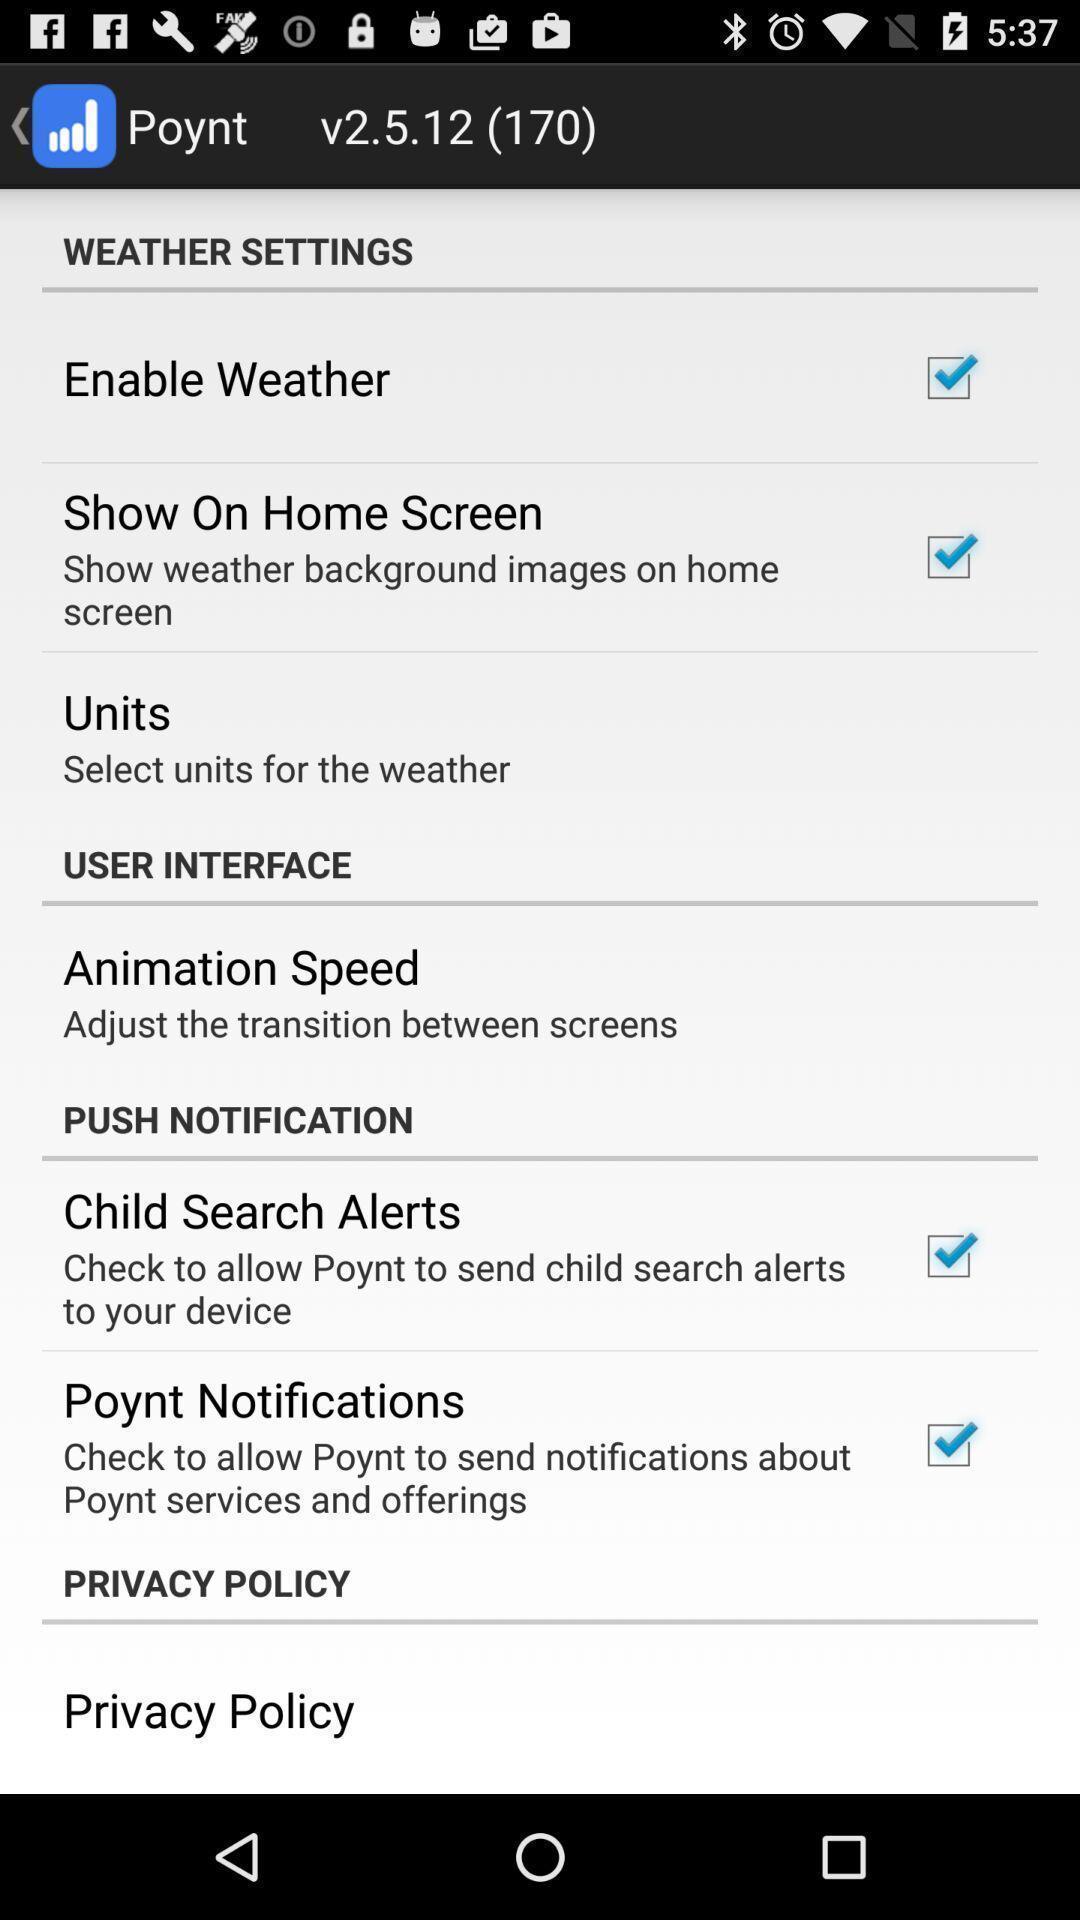What is the overall content of this screenshot? Weather settings list. 